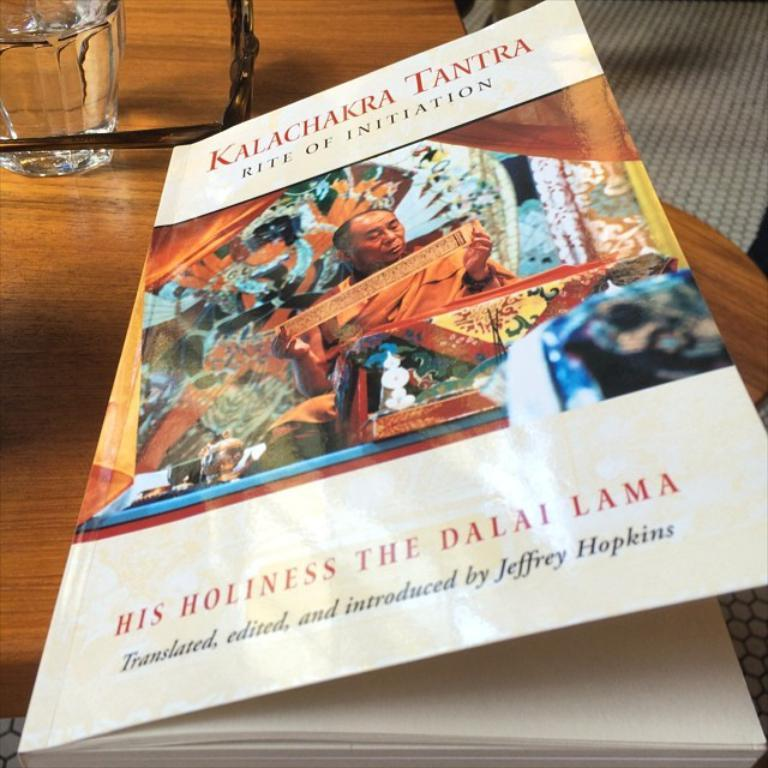<image>
Describe the image concisely. the word holiness is on a white book 